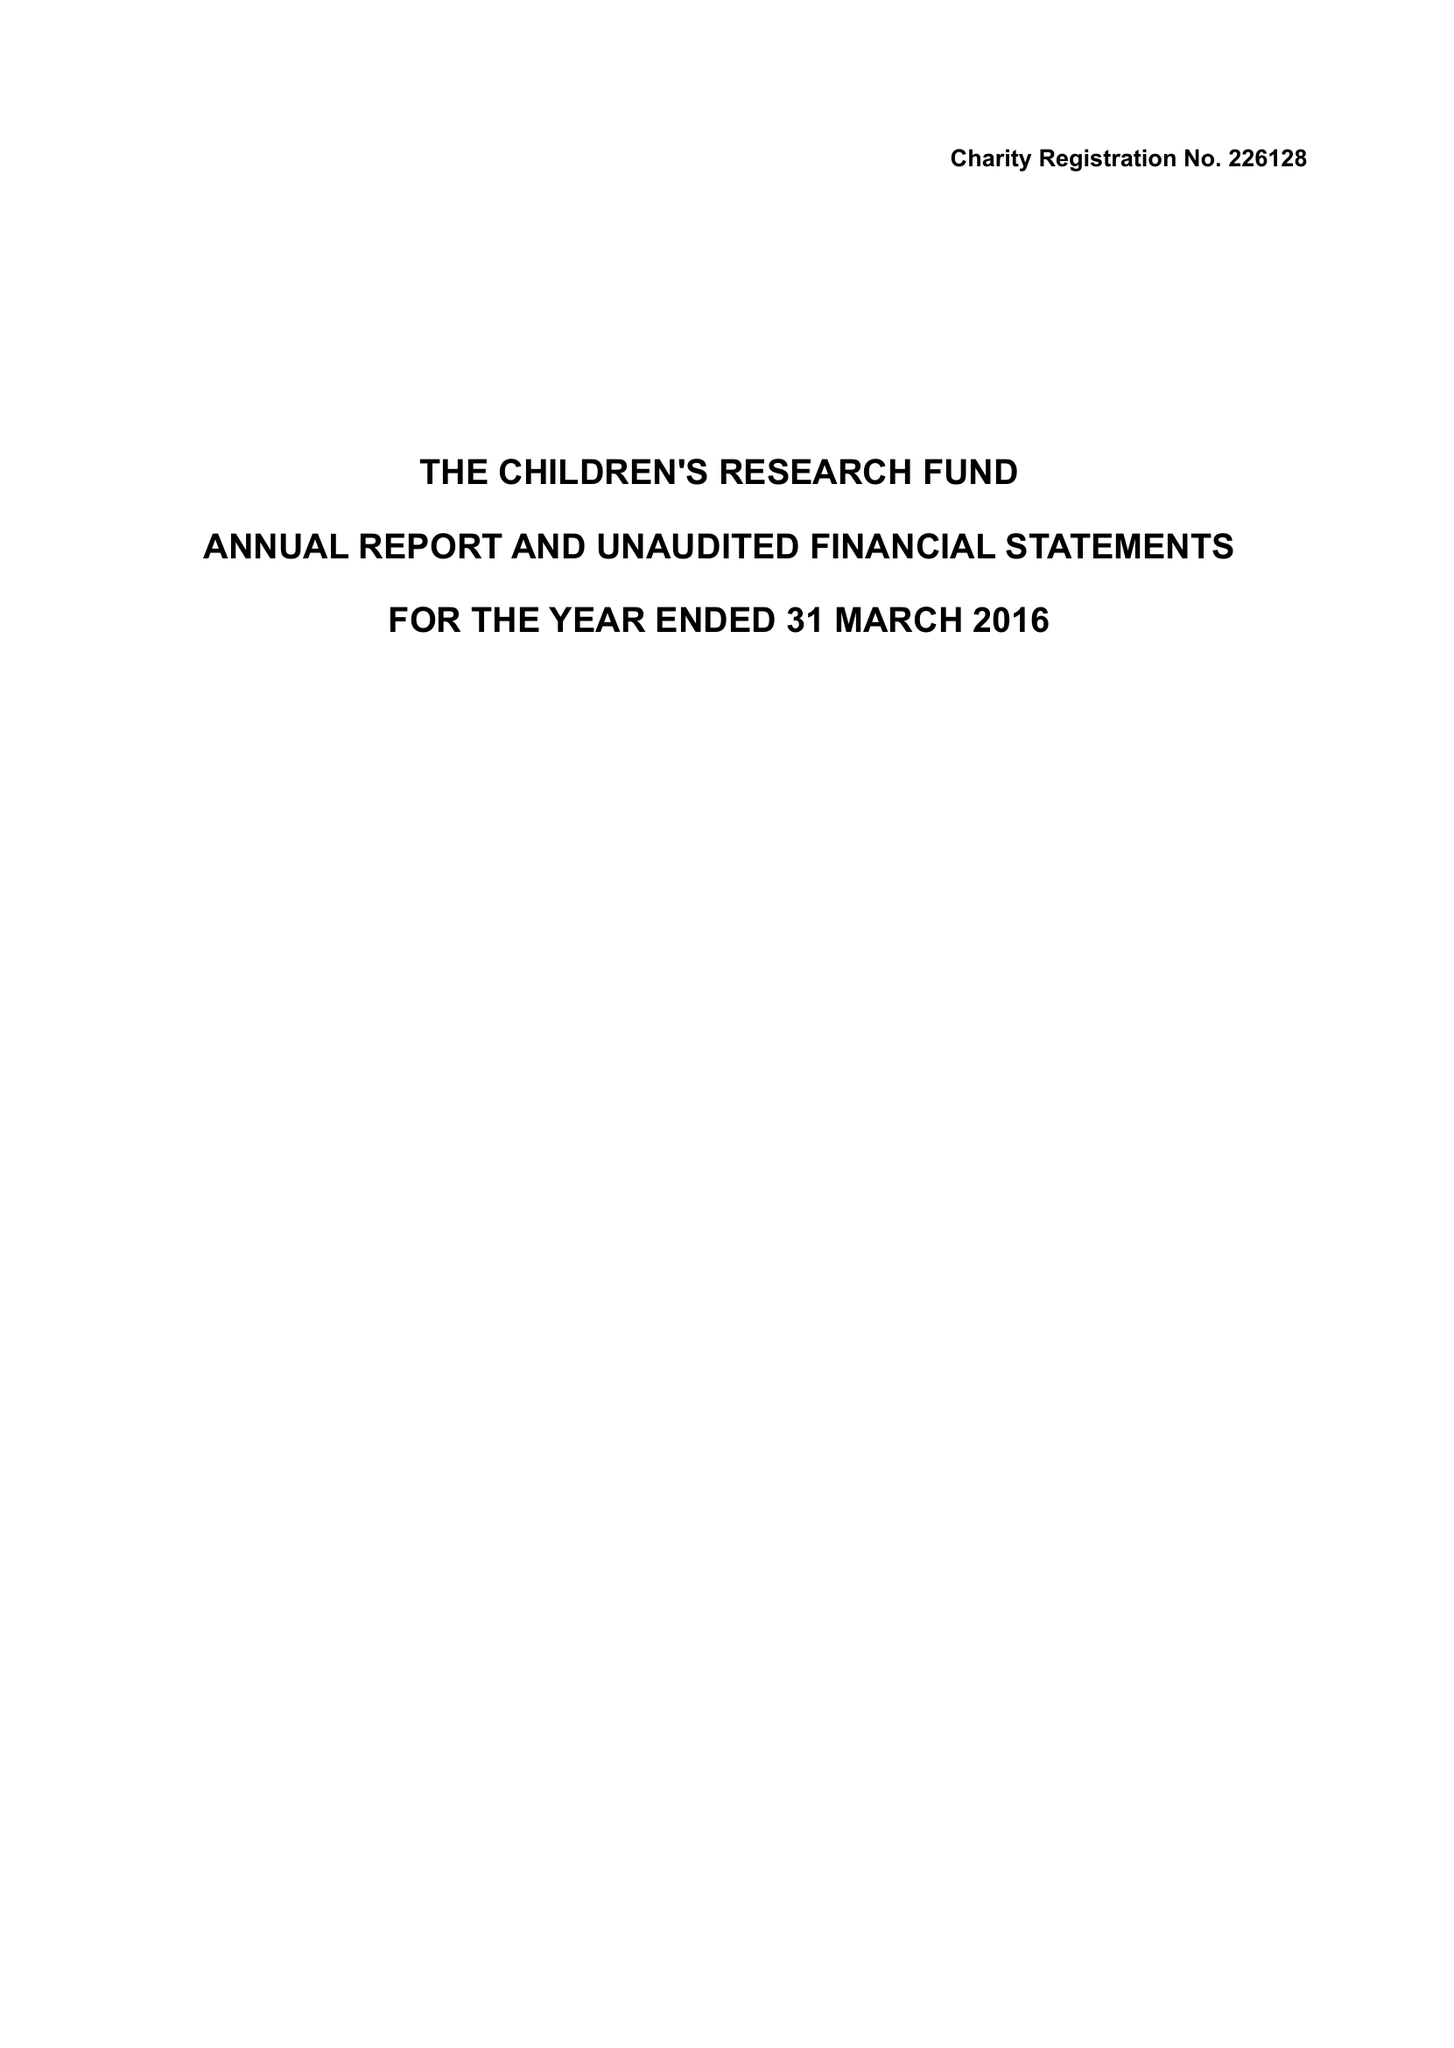What is the value for the address__street_line?
Answer the question using a single word or phrase. 14 TAN-Y-BRYN 